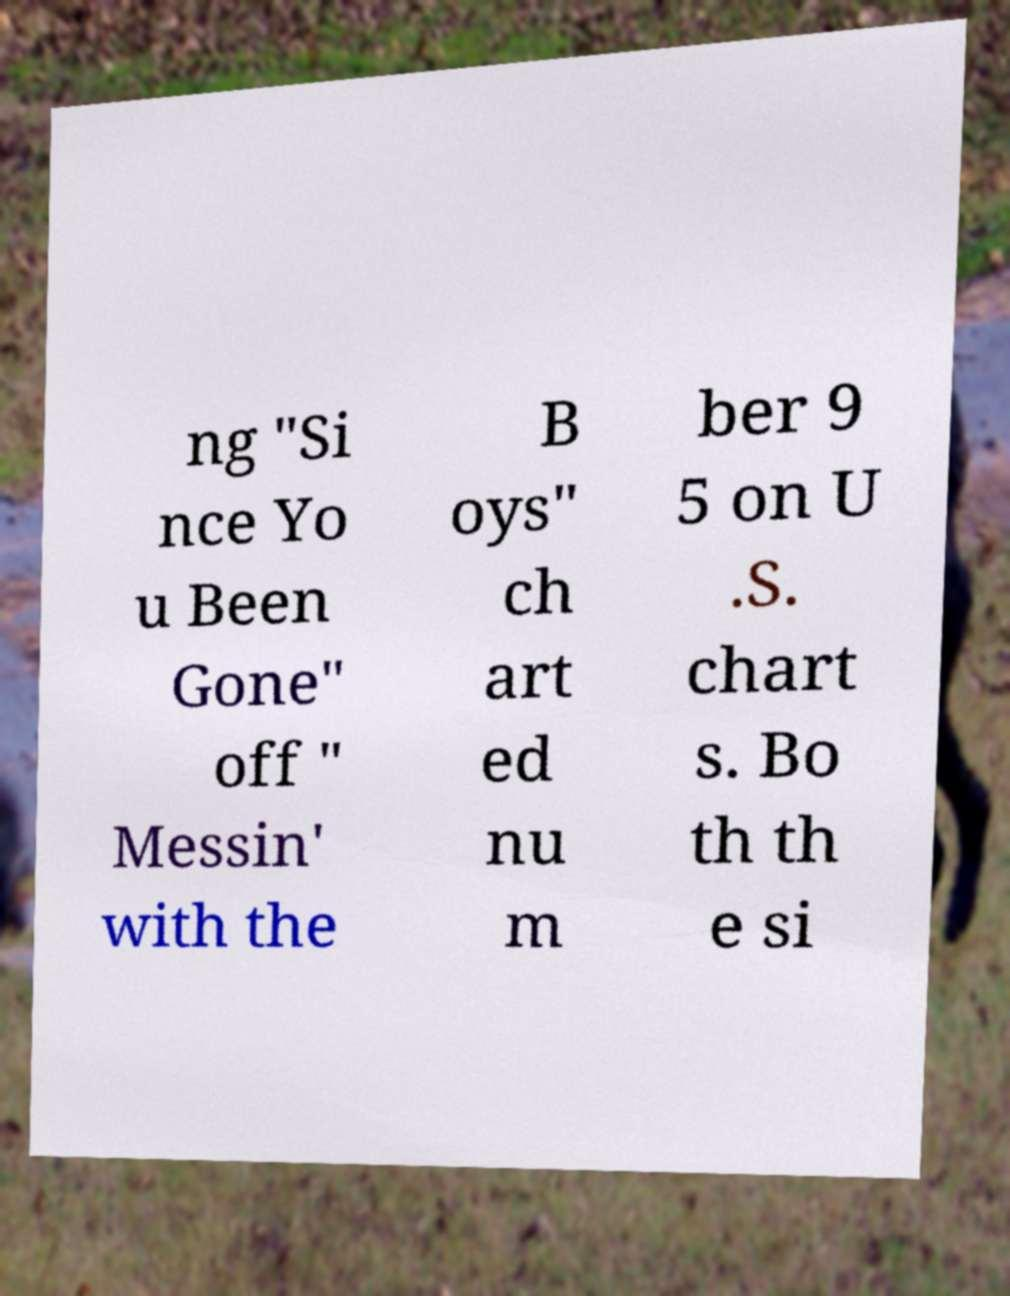Please identify and transcribe the text found in this image. ng "Si nce Yo u Been Gone" off " Messin' with the B oys" ch art ed nu m ber 9 5 on U .S. chart s. Bo th th e si 